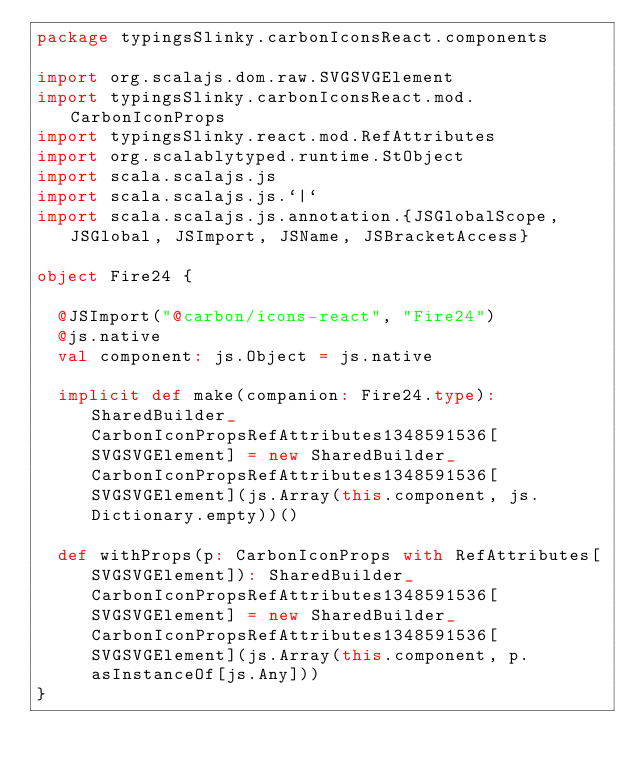<code> <loc_0><loc_0><loc_500><loc_500><_Scala_>package typingsSlinky.carbonIconsReact.components

import org.scalajs.dom.raw.SVGSVGElement
import typingsSlinky.carbonIconsReact.mod.CarbonIconProps
import typingsSlinky.react.mod.RefAttributes
import org.scalablytyped.runtime.StObject
import scala.scalajs.js
import scala.scalajs.js.`|`
import scala.scalajs.js.annotation.{JSGlobalScope, JSGlobal, JSImport, JSName, JSBracketAccess}

object Fire24 {
  
  @JSImport("@carbon/icons-react", "Fire24")
  @js.native
  val component: js.Object = js.native
  
  implicit def make(companion: Fire24.type): SharedBuilder_CarbonIconPropsRefAttributes1348591536[SVGSVGElement] = new SharedBuilder_CarbonIconPropsRefAttributes1348591536[SVGSVGElement](js.Array(this.component, js.Dictionary.empty))()
  
  def withProps(p: CarbonIconProps with RefAttributes[SVGSVGElement]): SharedBuilder_CarbonIconPropsRefAttributes1348591536[SVGSVGElement] = new SharedBuilder_CarbonIconPropsRefAttributes1348591536[SVGSVGElement](js.Array(this.component, p.asInstanceOf[js.Any]))
}
</code> 